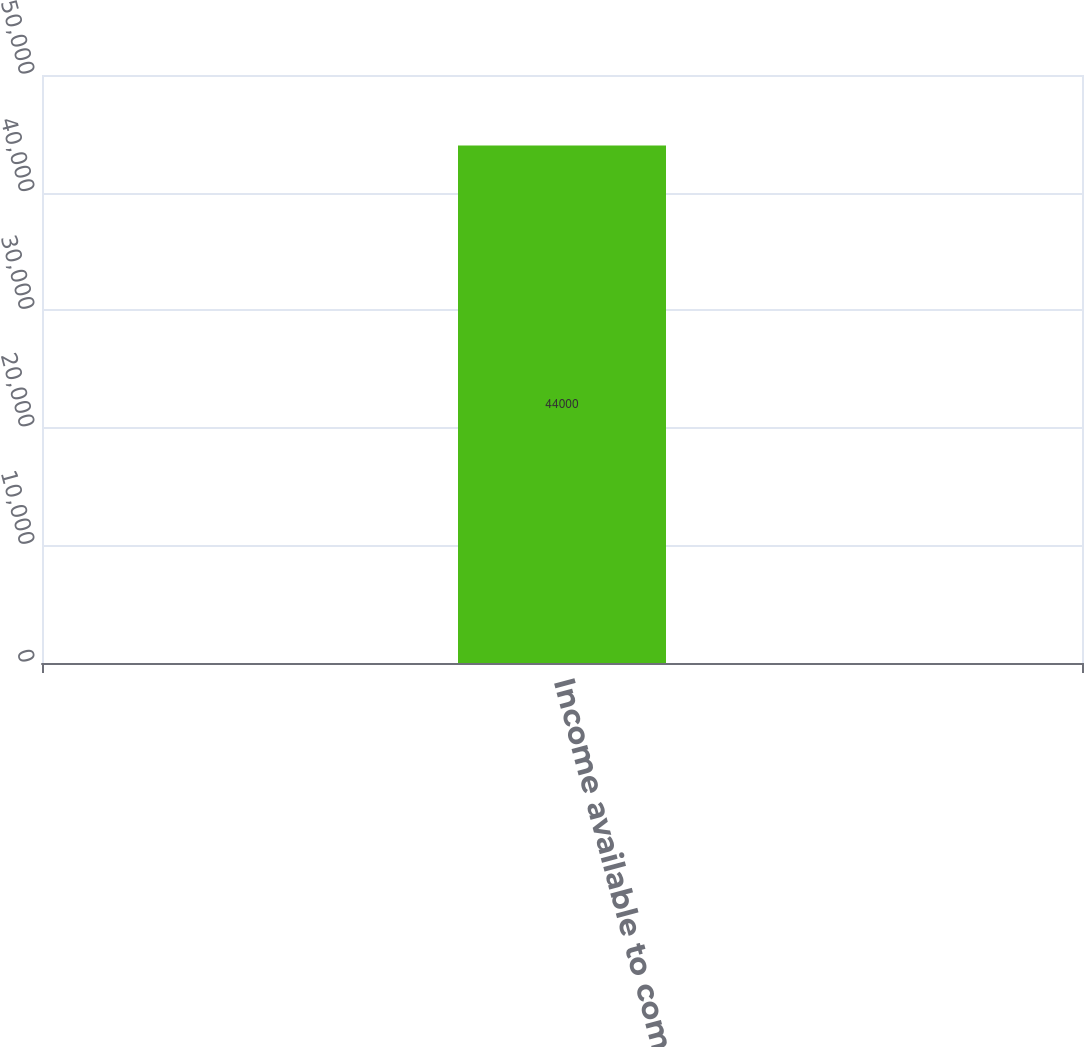<chart> <loc_0><loc_0><loc_500><loc_500><bar_chart><fcel>Income available to common<nl><fcel>44000<nl></chart> 